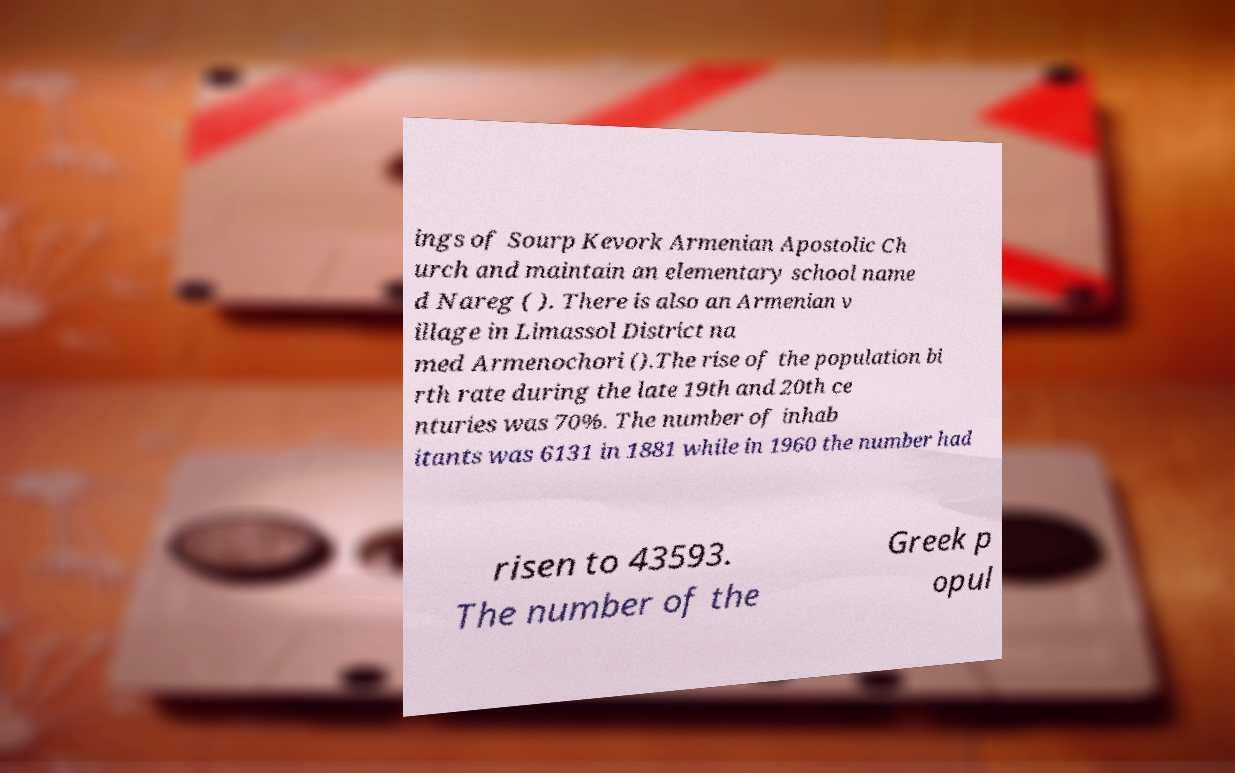Can you accurately transcribe the text from the provided image for me? ings of Sourp Kevork Armenian Apostolic Ch urch and maintain an elementary school name d Nareg ( ). There is also an Armenian v illage in Limassol District na med Armenochori ().The rise of the population bi rth rate during the late 19th and 20th ce nturies was 70%. The number of inhab itants was 6131 in 1881 while in 1960 the number had risen to 43593. The number of the Greek p opul 